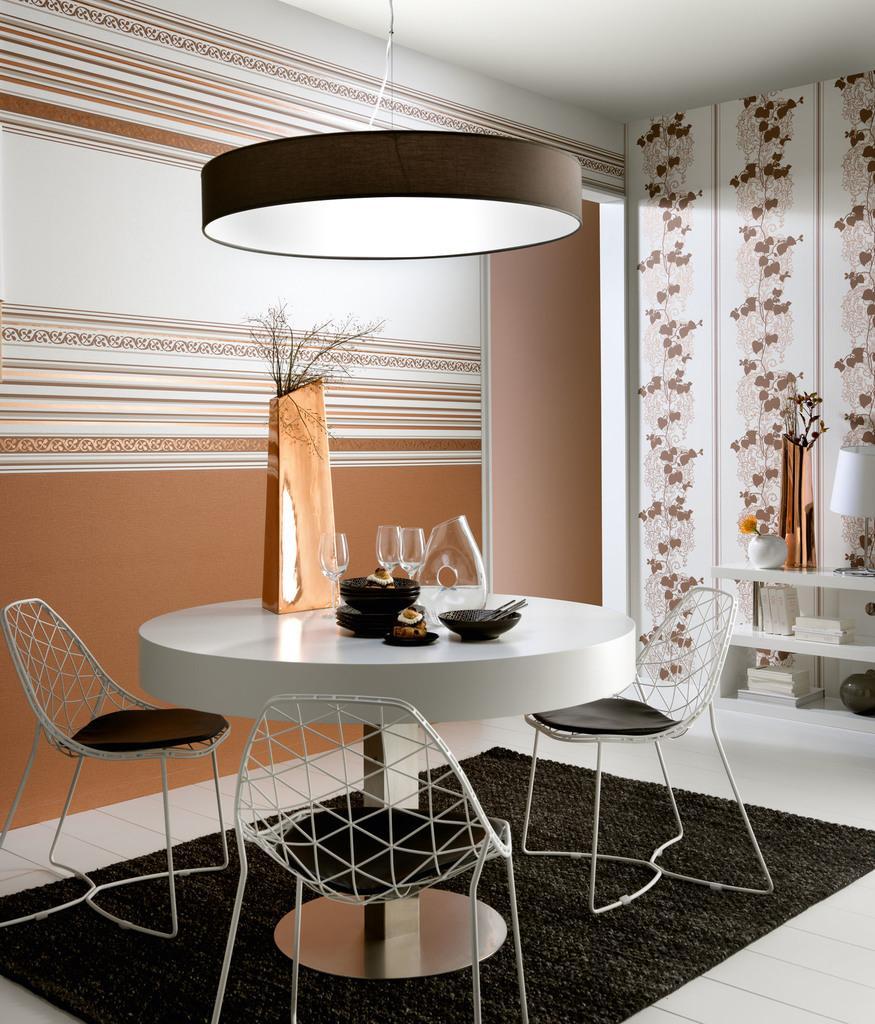Please provide a concise description of this image. In this picture I can see the glass, jar, cake, cup, spoons, pot, plants and other objects on the round table. Beside that I can see the chairs. At the bottom I can see the black carpet. At the top there is a light which is hanging from the roof. On the right I can see some lamp, books, pot, plant and other objects on the shelf. In the back I can see the wall. 